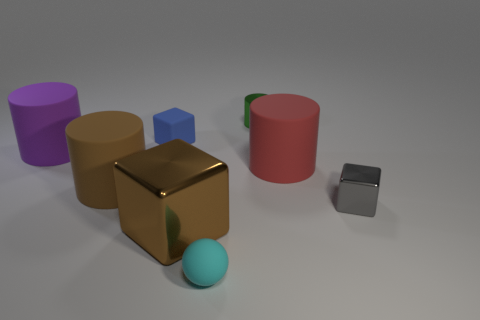Do the tiny cube that is in front of the purple object and the big red cylinder have the same material?
Offer a very short reply. No. What material is the cylinder that is the same color as the large metallic cube?
Your answer should be very brief. Rubber. Are there any other things that are the same shape as the tiny gray shiny object?
Make the answer very short. Yes. How many things are rubber blocks or large brown metallic blocks?
Offer a very short reply. 2. There is another metallic thing that is the same shape as the large brown shiny thing; what is its size?
Provide a succinct answer. Small. Are there any other things that have the same size as the purple cylinder?
Your answer should be compact. Yes. How many other things are the same color as the tiny shiny cube?
Give a very brief answer. 0. What number of cylinders are small gray things or big brown matte objects?
Your response must be concise. 1. What color is the matte object to the right of the cylinder behind the small matte cube?
Make the answer very short. Red. What is the shape of the small blue matte thing?
Ensure brevity in your answer.  Cube. 